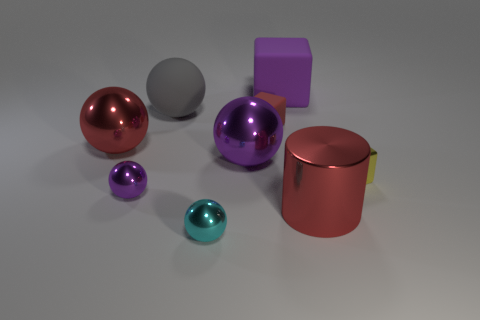There is a large cylinder that is the same color as the tiny rubber thing; what material is it?
Give a very brief answer. Metal. There is a tiny cube that is made of the same material as the small cyan ball; what color is it?
Your response must be concise. Yellow. Is the number of red metal objects less than the number of tiny purple matte balls?
Offer a terse response. No. What number of cyan objects are either small cubes or shiny cubes?
Keep it short and to the point. 0. What number of red things are right of the tiny cyan ball and to the left of the red cylinder?
Give a very brief answer. 1. Does the tiny yellow block have the same material as the small cyan object?
Offer a very short reply. Yes. What shape is the yellow metallic thing that is the same size as the cyan metallic object?
Give a very brief answer. Cube. Is the number of cylinders greater than the number of large yellow things?
Keep it short and to the point. Yes. What material is the purple thing that is both in front of the large matte sphere and to the right of the big gray rubber thing?
Ensure brevity in your answer.  Metal. How many other things are there of the same material as the big red cylinder?
Keep it short and to the point. 5. 